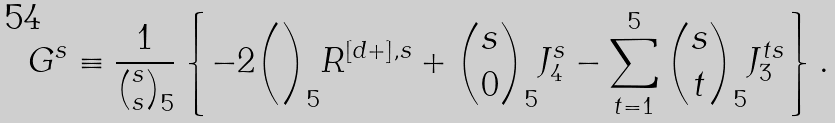<formula> <loc_0><loc_0><loc_500><loc_500>G ^ { s } \equiv \frac { 1 } { { s \choose s } _ { 5 } } \left \{ - 2 { \choose } _ { 5 } R ^ { [ d + ] , s } + { s \choose 0 } _ { 5 } J _ { 4 } ^ { s } - \sum _ { t = 1 } ^ { 5 } { s \choose t } _ { 5 } J _ { 3 } ^ { t s } \right \} .</formula> 